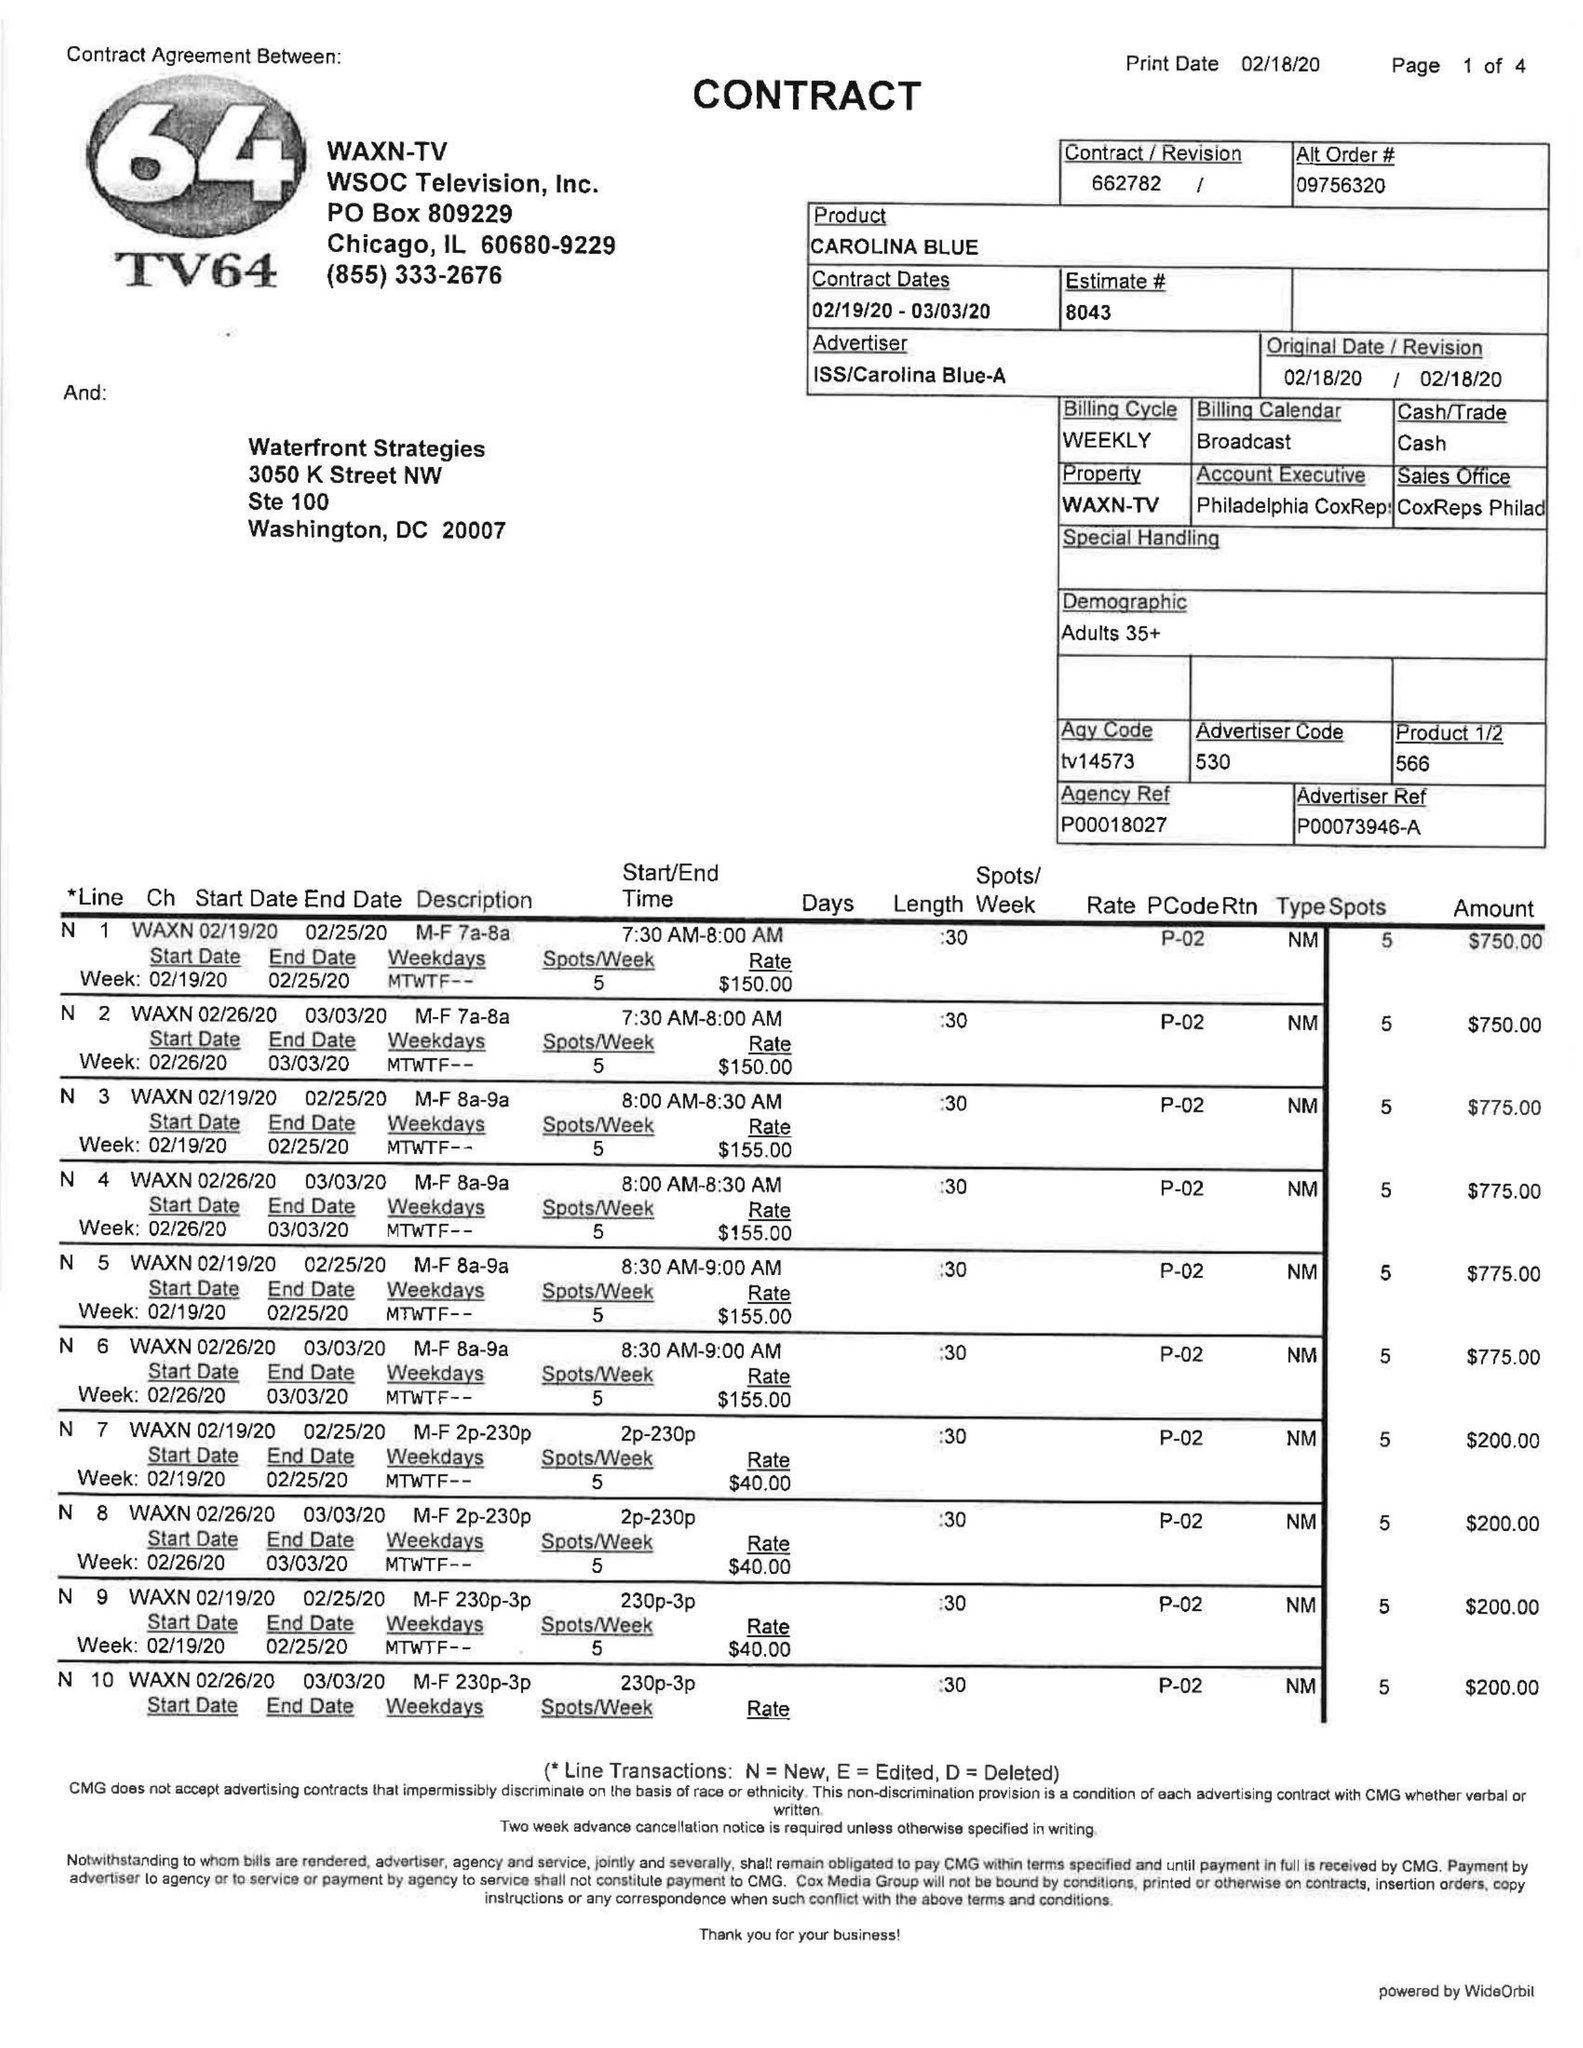What is the value for the flight_to?
Answer the question using a single word or phrase. 03/03/20 